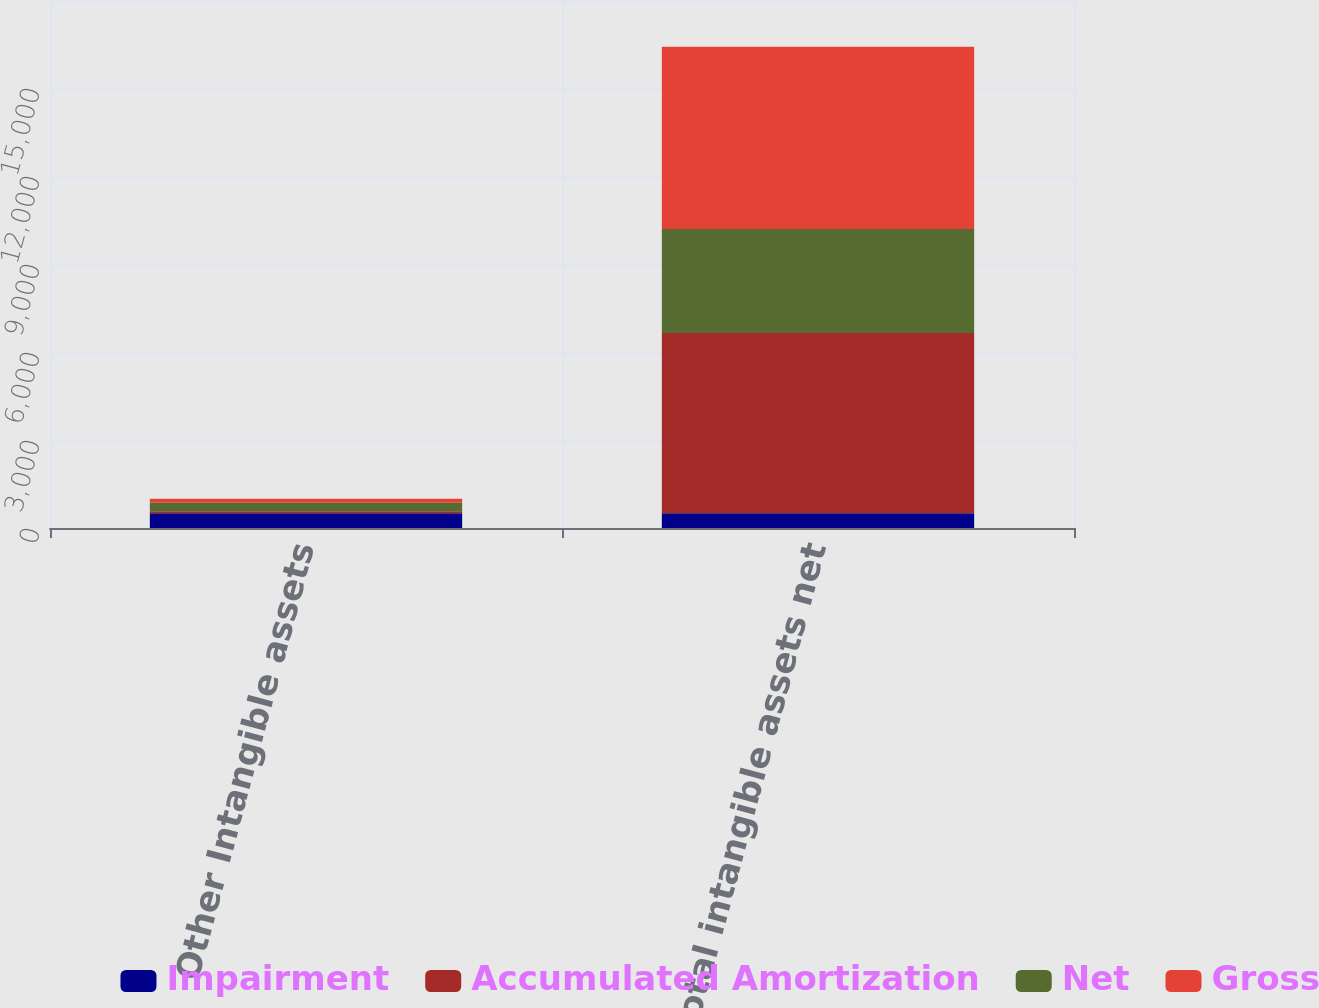Convert chart to OTSL. <chart><loc_0><loc_0><loc_500><loc_500><stacked_bar_chart><ecel><fcel>Other Intangible assets<fcel>Total intangible assets net<nl><fcel>Impairment<fcel>500<fcel>500<nl><fcel>Accumulated Amortization<fcel>74<fcel>6148<nl><fcel>Net<fcel>291<fcel>3541<nl><fcel>Gross<fcel>135<fcel>6221<nl></chart> 